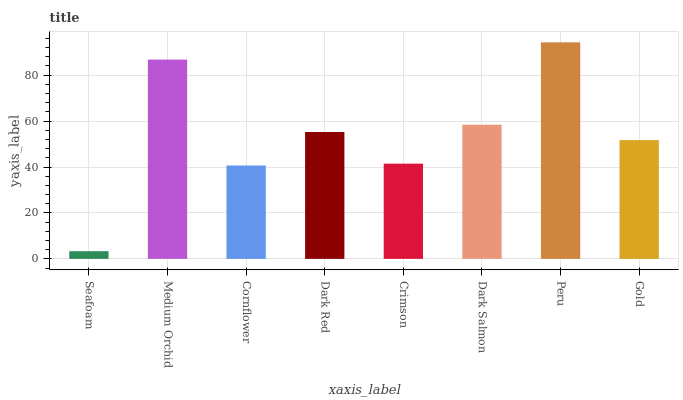Is Seafoam the minimum?
Answer yes or no. Yes. Is Peru the maximum?
Answer yes or no. Yes. Is Medium Orchid the minimum?
Answer yes or no. No. Is Medium Orchid the maximum?
Answer yes or no. No. Is Medium Orchid greater than Seafoam?
Answer yes or no. Yes. Is Seafoam less than Medium Orchid?
Answer yes or no. Yes. Is Seafoam greater than Medium Orchid?
Answer yes or no. No. Is Medium Orchid less than Seafoam?
Answer yes or no. No. Is Dark Red the high median?
Answer yes or no. Yes. Is Gold the low median?
Answer yes or no. Yes. Is Peru the high median?
Answer yes or no. No. Is Dark Salmon the low median?
Answer yes or no. No. 